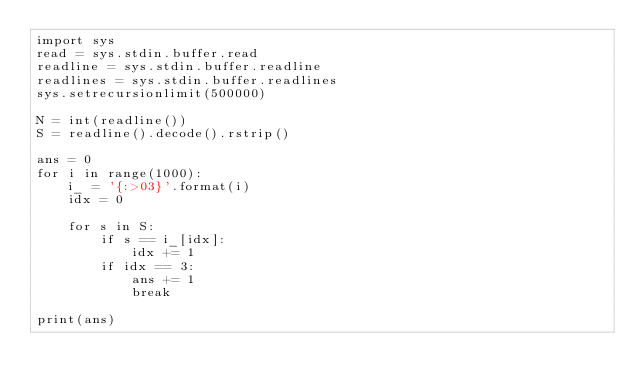<code> <loc_0><loc_0><loc_500><loc_500><_Python_>import sys
read = sys.stdin.buffer.read
readline = sys.stdin.buffer.readline
readlines = sys.stdin.buffer.readlines
sys.setrecursionlimit(500000)

N = int(readline())
S = readline().decode().rstrip()

ans = 0
for i in range(1000):
    i_ = '{:>03}'.format(i)
    idx = 0

    for s in S:
        if s == i_[idx]:
            idx += 1
        if idx == 3:
            ans += 1
            break

print(ans)
</code> 